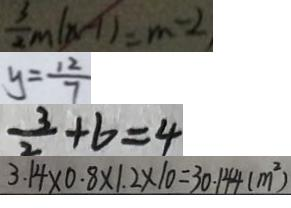<formula> <loc_0><loc_0><loc_500><loc_500>\frac { 3 } { 2 } m ( n - 1 ) = m - 2 
 y = \frac { 1 2 } { 7 } 
 \frac { 3 } { 2 } + b = 4 
 3 . 1 4 \times 0 . 8 \times 1 . 2 \times 1 0 = 3 0 . 1 4 4 ( m ^ { 2 } )</formula> 